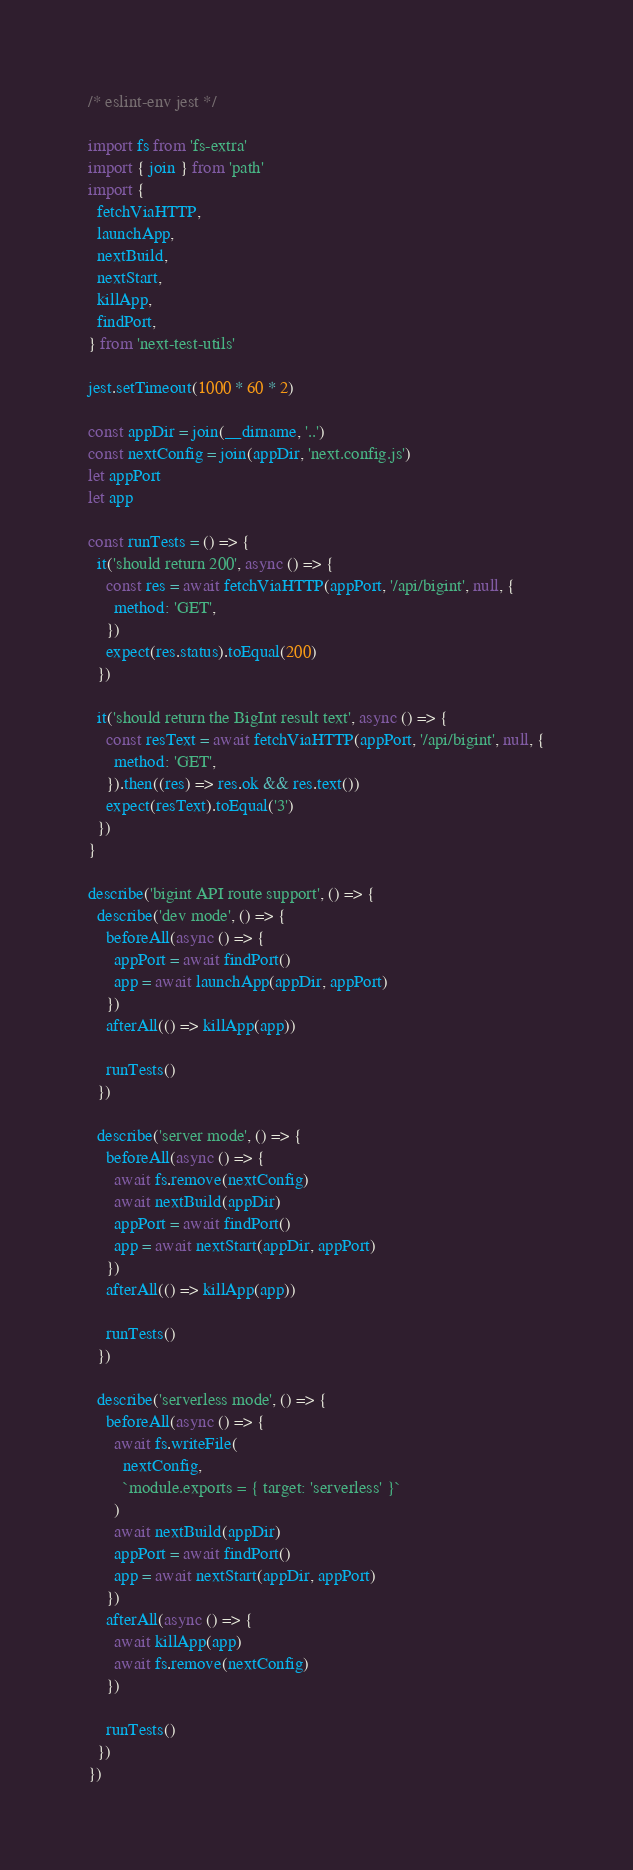<code> <loc_0><loc_0><loc_500><loc_500><_JavaScript_>/* eslint-env jest */

import fs from 'fs-extra'
import { join } from 'path'
import {
  fetchViaHTTP,
  launchApp,
  nextBuild,
  nextStart,
  killApp,
  findPort,
} from 'next-test-utils'

jest.setTimeout(1000 * 60 * 2)

const appDir = join(__dirname, '..')
const nextConfig = join(appDir, 'next.config.js')
let appPort
let app

const runTests = () => {
  it('should return 200', async () => {
    const res = await fetchViaHTTP(appPort, '/api/bigint', null, {
      method: 'GET',
    })
    expect(res.status).toEqual(200)
  })

  it('should return the BigInt result text', async () => {
    const resText = await fetchViaHTTP(appPort, '/api/bigint', null, {
      method: 'GET',
    }).then((res) => res.ok && res.text())
    expect(resText).toEqual('3')
  })
}

describe('bigint API route support', () => {
  describe('dev mode', () => {
    beforeAll(async () => {
      appPort = await findPort()
      app = await launchApp(appDir, appPort)
    })
    afterAll(() => killApp(app))

    runTests()
  })

  describe('server mode', () => {
    beforeAll(async () => {
      await fs.remove(nextConfig)
      await nextBuild(appDir)
      appPort = await findPort()
      app = await nextStart(appDir, appPort)
    })
    afterAll(() => killApp(app))

    runTests()
  })

  describe('serverless mode', () => {
    beforeAll(async () => {
      await fs.writeFile(
        nextConfig,
        `module.exports = { target: 'serverless' }`
      )
      await nextBuild(appDir)
      appPort = await findPort()
      app = await nextStart(appDir, appPort)
    })
    afterAll(async () => {
      await killApp(app)
      await fs.remove(nextConfig)
    })

    runTests()
  })
})
</code> 